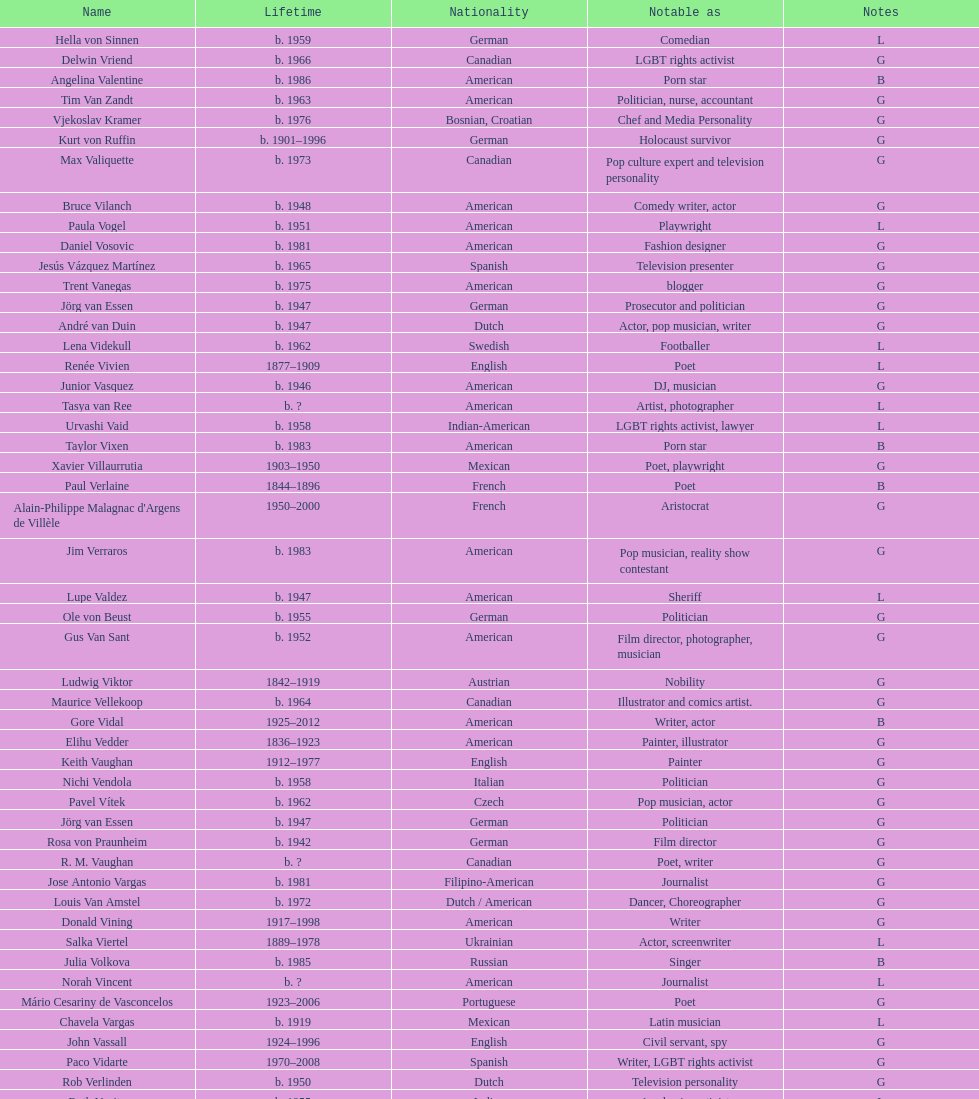What is the gap in birth years between vachon and vaid? 4 years. Could you parse the entire table? {'header': ['Name', 'Lifetime', 'Nationality', 'Notable as', 'Notes'], 'rows': [['Hella von Sinnen', 'b. 1959', 'German', 'Comedian', 'L'], ['Delwin Vriend', 'b. 1966', 'Canadian', 'LGBT rights activist', 'G'], ['Angelina Valentine', 'b. 1986', 'American', 'Porn star', 'B'], ['Tim Van Zandt', 'b. 1963', 'American', 'Politician, nurse, accountant', 'G'], ['Vjekoslav Kramer', 'b. 1976', 'Bosnian, Croatian', 'Chef and Media Personality', 'G'], ['Kurt von Ruffin', 'b. 1901–1996', 'German', 'Holocaust survivor', 'G'], ['Max Valiquette', 'b. 1973', 'Canadian', 'Pop culture expert and television personality', 'G'], ['Bruce Vilanch', 'b. 1948', 'American', 'Comedy writer, actor', 'G'], ['Paula Vogel', 'b. 1951', 'American', 'Playwright', 'L'], ['Daniel Vosovic', 'b. 1981', 'American', 'Fashion designer', 'G'], ['Jesús Vázquez Martínez', 'b. 1965', 'Spanish', 'Television presenter', 'G'], ['Trent Vanegas', 'b. 1975', 'American', 'blogger', 'G'], ['Jörg van Essen', 'b. 1947', 'German', 'Prosecutor and politician', 'G'], ['André van Duin', 'b. 1947', 'Dutch', 'Actor, pop musician, writer', 'G'], ['Lena Videkull', 'b. 1962', 'Swedish', 'Footballer', 'L'], ['Renée Vivien', '1877–1909', 'English', 'Poet', 'L'], ['Junior Vasquez', 'b. 1946', 'American', 'DJ, musician', 'G'], ['Tasya van Ree', 'b.\xa0?', 'American', 'Artist, photographer', 'L'], ['Urvashi Vaid', 'b. 1958', 'Indian-American', 'LGBT rights activist, lawyer', 'L'], ['Taylor Vixen', 'b. 1983', 'American', 'Porn star', 'B'], ['Xavier Villaurrutia', '1903–1950', 'Mexican', 'Poet, playwright', 'G'], ['Paul Verlaine', '1844–1896', 'French', 'Poet', 'B'], ["Alain-Philippe Malagnac d'Argens de Villèle", '1950–2000', 'French', 'Aristocrat', 'G'], ['Jim Verraros', 'b. 1983', 'American', 'Pop musician, reality show contestant', 'G'], ['Lupe Valdez', 'b. 1947', 'American', 'Sheriff', 'L'], ['Ole von Beust', 'b. 1955', 'German', 'Politician', 'G'], ['Gus Van Sant', 'b. 1952', 'American', 'Film director, photographer, musician', 'G'], ['Ludwig Viktor', '1842–1919', 'Austrian', 'Nobility', 'G'], ['Maurice Vellekoop', 'b. 1964', 'Canadian', 'Illustrator and comics artist.', 'G'], ['Gore Vidal', '1925–2012', 'American', 'Writer, actor', 'B'], ['Elihu Vedder', '1836–1923', 'American', 'Painter, illustrator', 'G'], ['Keith Vaughan', '1912–1977', 'English', 'Painter', 'G'], ['Nichi Vendola', 'b. 1958', 'Italian', 'Politician', 'G'], ['Pavel Vítek', 'b. 1962', 'Czech', 'Pop musician, actor', 'G'], ['Jörg van Essen', 'b. 1947', 'German', 'Politician', 'G'], ['Rosa von Praunheim', 'b. 1942', 'German', 'Film director', 'G'], ['R. M. Vaughan', 'b.\xa0?', 'Canadian', 'Poet, writer', 'G'], ['Jose Antonio Vargas', 'b. 1981', 'Filipino-American', 'Journalist', 'G'], ['Louis Van Amstel', 'b. 1972', 'Dutch / American', 'Dancer, Choreographer', 'G'], ['Donald Vining', '1917–1998', 'American', 'Writer', 'G'], ['Salka Viertel', '1889–1978', 'Ukrainian', 'Actor, screenwriter', 'L'], ['Julia Volkova', 'b. 1985', 'Russian', 'Singer', 'B'], ['Norah Vincent', 'b.\xa0?', 'American', 'Journalist', 'L'], ['Mário Cesariny de Vasconcelos', '1923–2006', 'Portuguese', 'Poet', 'G'], ['Chavela Vargas', 'b. 1919', 'Mexican', 'Latin musician', 'L'], ['John Vassall', '1924–1996', 'English', 'Civil servant, spy', 'G'], ['Paco Vidarte', '1970–2008', 'Spanish', 'Writer, LGBT rights activist', 'G'], ['Rob Verlinden', 'b. 1950', 'Dutch', 'Television personality', 'G'], ['Ruth Vanita', 'b. 1955', 'Indian', 'Academic, activist', 'L'], ['Claude Vivier', '1948–1983', 'Canadian', '20th century classical composer', 'G'], ['Arthur H. Vandenberg, Jr.', 'b. 1907', 'American', 'government official, politician', 'G'], ['António Variações', '1944–1984', 'Portuguese', 'Pop musician', 'G'], ['Gianni Versace', '1946–1997', 'Italian', 'Fashion designer', 'G'], ['Wilhelm von Gloeden', '1856–1931', 'German', 'Photographer', 'G'], ['Théophile de Viau', '1590–1626', 'French', 'Poet, dramatist', 'G'], ['Jennifer Veiga', 'b. 1962', 'American', 'Politician', 'L'], ['Ron Vawter', '1948–1994', 'American', 'Actor', 'G'], ['Bruce Voeller', '1934–1994', 'American', 'HIV/AIDS researcher', 'G'], ['Börje Vestlund', 'b. 1960', 'Swedish', 'Politician', 'G'], ['Luchino Visconti', '1906–1976', 'Italian', 'Filmmaker', 'G'], ['Reg Vermue', 'b.\xa0?', 'Canadian', 'Rock musician', 'G'], ['Werner Veigel', '1928–1995', 'German', 'News presenter', 'G'], ['Anthony Venn-Brown', 'b. 1951', 'Australian', 'Author, former evangelist', 'G'], ['Carmen Vázquez', 'b.\xa0?', 'Cuban-American', 'Activist, writer', 'L'], ['Carl Van Vechten', '1880–1964', 'American', 'Writer, photographer', 'G'], ['Patricia Velásquez', 'b. 1971', 'Venezuelan', 'Actor, model', 'B'], ['Tom Villard', '1953–1994', 'American', 'Actor', 'G'], ['Christine Vachon', 'b. 1962', 'American', 'Film producer', 'L'], ['Gerda Verburg', 'b. 1957', 'Dutch', 'Politician', 'L'], ['Gianni Vattimo', 'b. 1936', 'Italian', 'Writer, philosopher', 'G'], ['José Villarrubia', 'b. 1961', 'American', 'Artist', 'G'], ['Nick Verreos', 'b. 1967', 'American', 'Fashion designer', 'G'], ['Pierre Vallières', '1938–1998', 'Québécois', 'Journalist, writer', 'G']]} 